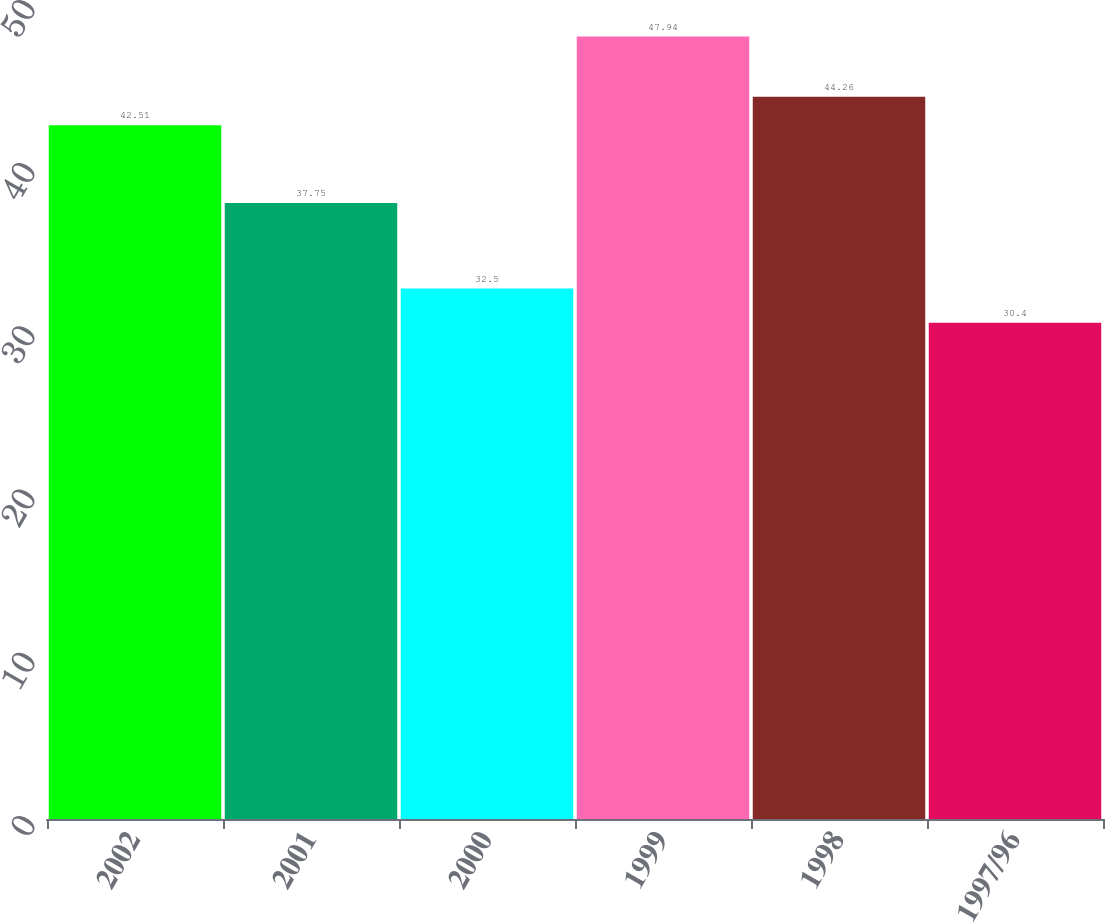<chart> <loc_0><loc_0><loc_500><loc_500><bar_chart><fcel>2002<fcel>2001<fcel>2000<fcel>1999<fcel>1998<fcel>1997/96<nl><fcel>42.51<fcel>37.75<fcel>32.5<fcel>47.94<fcel>44.26<fcel>30.4<nl></chart> 